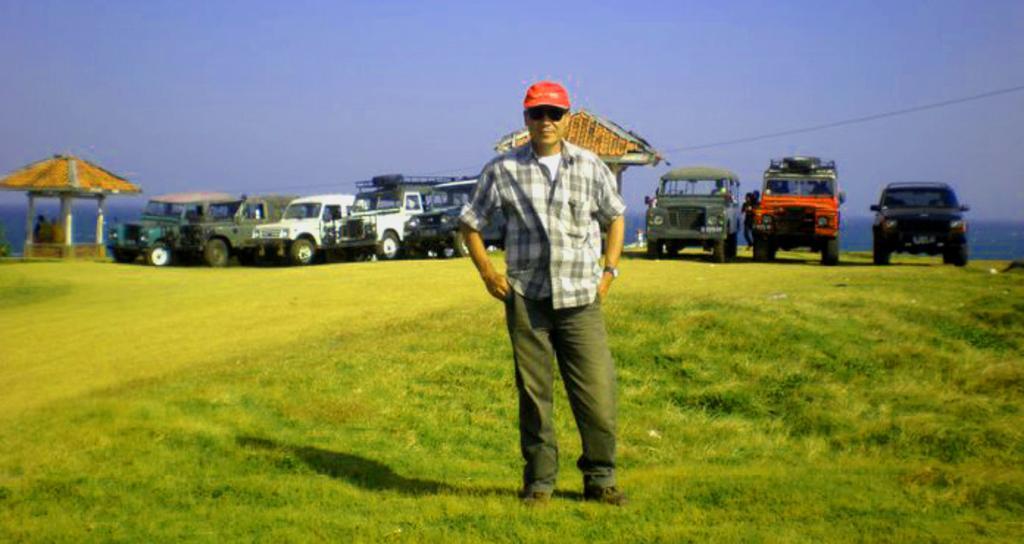Could you give a brief overview of what you see in this image? In this picture we can see a man wore cap, goggle and standing on the ground, vehicles, sheds and in the background we can see the sky. 